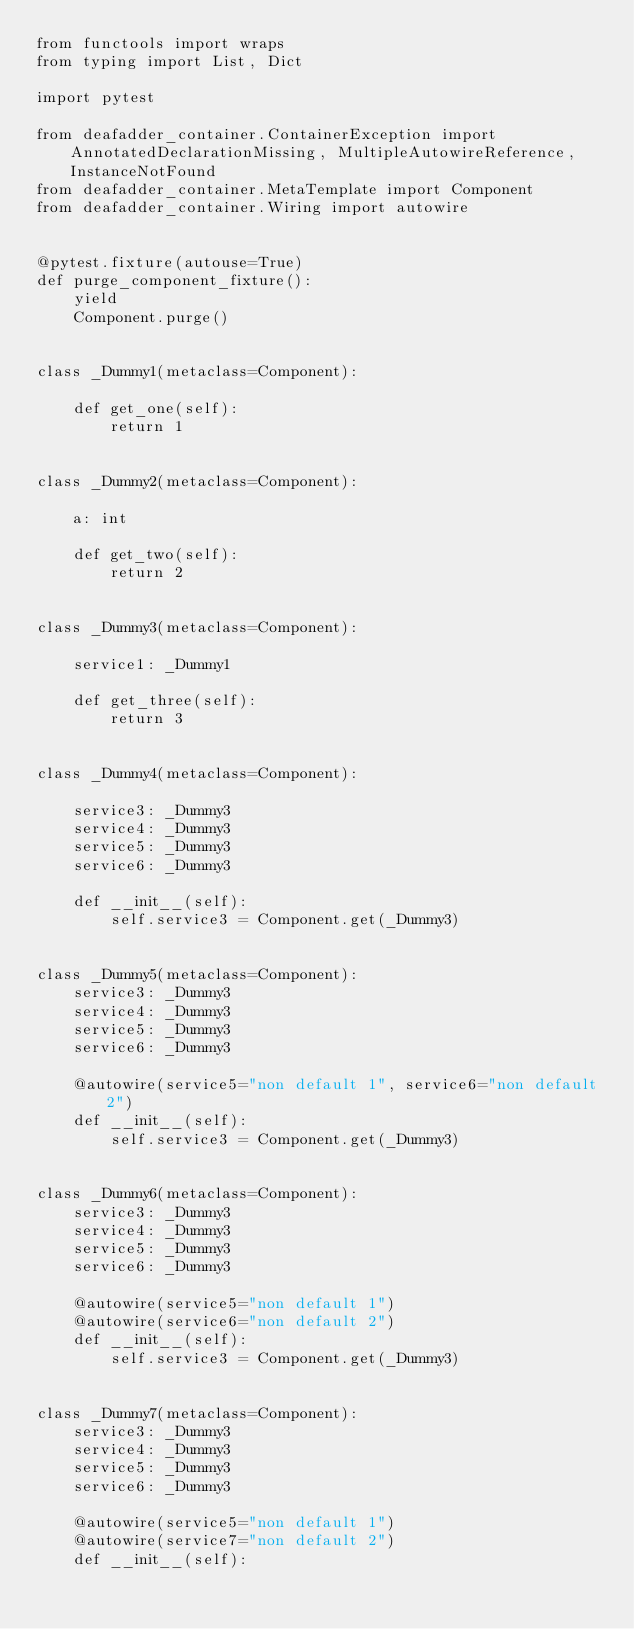<code> <loc_0><loc_0><loc_500><loc_500><_Python_>from functools import wraps
from typing import List, Dict

import pytest

from deafadder_container.ContainerException import AnnotatedDeclarationMissing, MultipleAutowireReference, InstanceNotFound
from deafadder_container.MetaTemplate import Component
from deafadder_container.Wiring import autowire


@pytest.fixture(autouse=True)
def purge_component_fixture():
    yield
    Component.purge()


class _Dummy1(metaclass=Component):

    def get_one(self):
        return 1


class _Dummy2(metaclass=Component):

    a: int

    def get_two(self):
        return 2


class _Dummy3(metaclass=Component):

    service1: _Dummy1

    def get_three(self):
        return 3


class _Dummy4(metaclass=Component):

    service3: _Dummy3
    service4: _Dummy3
    service5: _Dummy3
    service6: _Dummy3

    def __init__(self):
        self.service3 = Component.get(_Dummy3)


class _Dummy5(metaclass=Component):
    service3: _Dummy3
    service4: _Dummy3
    service5: _Dummy3
    service6: _Dummy3

    @autowire(service5="non default 1", service6="non default 2")
    def __init__(self):
        self.service3 = Component.get(_Dummy3)


class _Dummy6(metaclass=Component):
    service3: _Dummy3
    service4: _Dummy3
    service5: _Dummy3
    service6: _Dummy3

    @autowire(service5="non default 1")
    @autowire(service6="non default 2")
    def __init__(self):
        self.service3 = Component.get(_Dummy3)


class _Dummy7(metaclass=Component):
    service3: _Dummy3
    service4: _Dummy3
    service5: _Dummy3
    service6: _Dummy3

    @autowire(service5="non default 1")
    @autowire(service7="non default 2")
    def __init__(self):</code> 